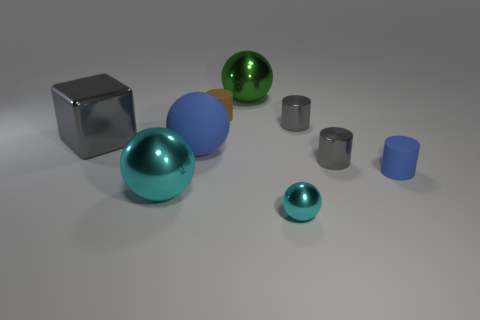What is the color of the big thing to the right of the rubber cylinder left of the tiny object that is in front of the small blue object?
Provide a short and direct response. Green. There is a big thing that is the same color as the small sphere; what is its shape?
Offer a very short reply. Sphere. There is a gray thing that is in front of the big gray block; how big is it?
Your answer should be compact. Small. There is a gray shiny object that is the same size as the blue matte ball; what shape is it?
Make the answer very short. Cube. Does the ball that is right of the large green metal thing have the same material as the gray object left of the brown matte cylinder?
Your response must be concise. Yes. There is a tiny cylinder to the left of the big metal ball that is behind the brown matte cylinder; what is its material?
Offer a terse response. Rubber. There is a gray thing that is to the left of the tiny ball that is in front of the thing to the left of the large cyan metallic sphere; how big is it?
Keep it short and to the point. Large. Is the size of the brown cylinder the same as the blue rubber cylinder?
Offer a very short reply. Yes. There is a gray shiny object that is left of the big blue thing; is it the same shape as the tiny gray thing behind the big blue matte thing?
Your answer should be compact. No. There is a large metallic thing on the right side of the big cyan metal sphere; is there a small gray thing behind it?
Give a very brief answer. No. 